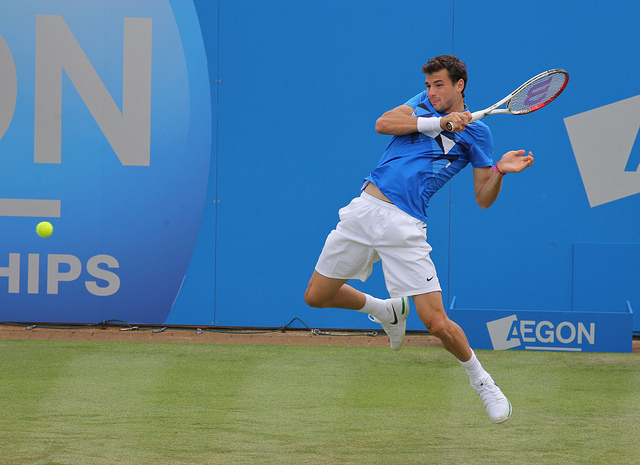Identify and read out the text in this image. N HIPS AEGON E 